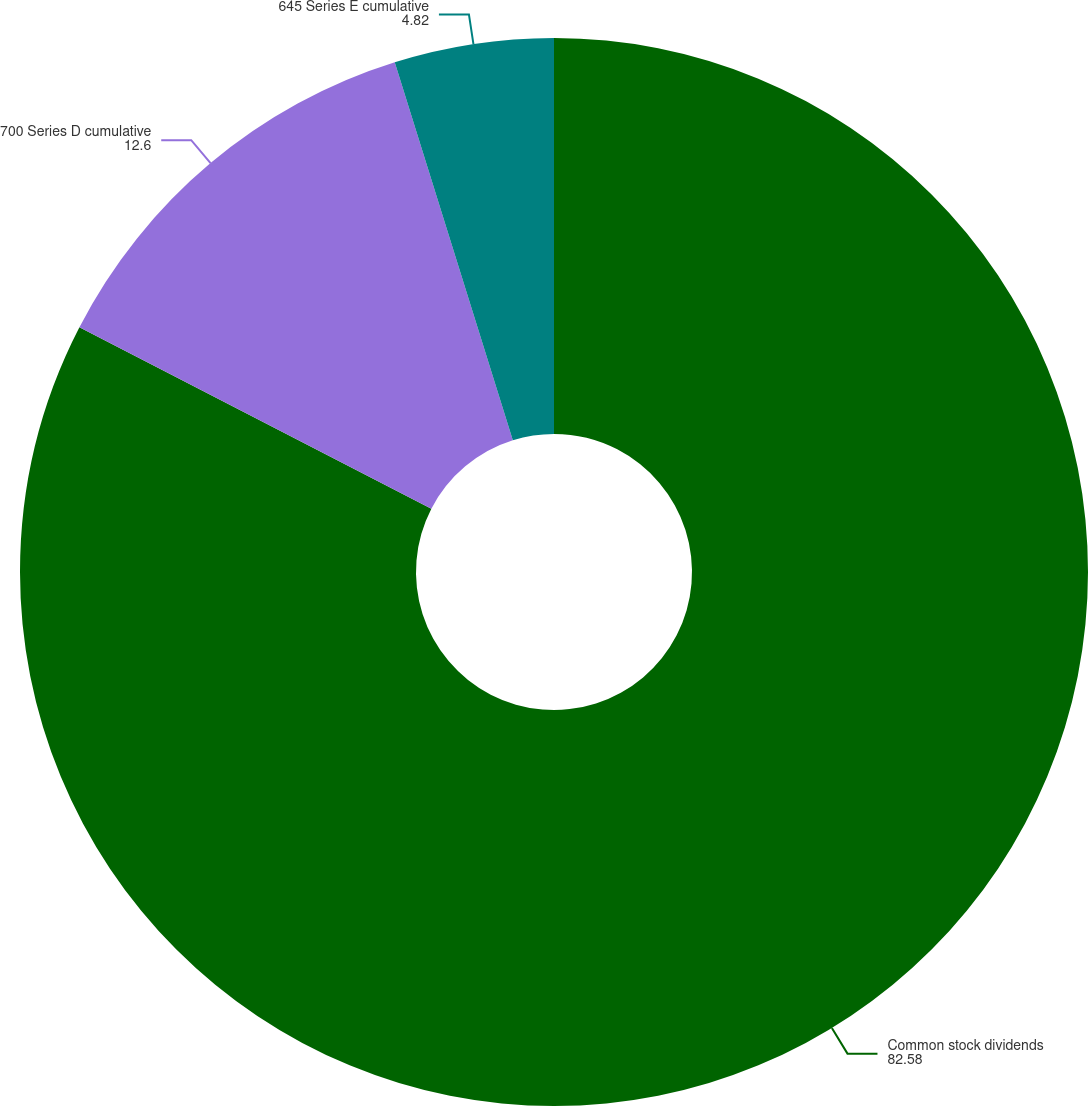<chart> <loc_0><loc_0><loc_500><loc_500><pie_chart><fcel>Common stock dividends<fcel>700 Series D cumulative<fcel>645 Series E cumulative<nl><fcel>82.58%<fcel>12.6%<fcel>4.82%<nl></chart> 